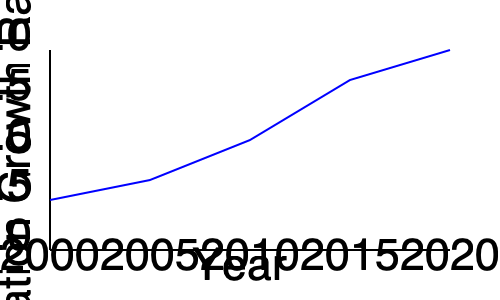Based on the line graph showing Nigeria's population growth rate from 2000 to 2020, calculate the average change in growth rate per year during this period. Express your answer as a percentage with two decimal places. To calculate the average change in growth rate per year:

1. Identify the starting and ending points:
   - 2000: 2.5%
   - 2020: 4.0%

2. Calculate the total change in growth rate:
   $4.0\% - 2.5\% = 1.5\%$

3. Determine the number of years in the period:
   $2020 - 2000 = 20$ years

4. Calculate the average change per year:
   $\frac{\text{Total change}}{\text{Number of years}} = \frac{1.5\%}{20} = 0.075\%$

5. Express the result as a percentage with two decimal places:
   $0.075\% = 0.08\%$ (rounded to two decimal places)

Therefore, the average change in Nigeria's population growth rate per year from 2000 to 2020 was 0.08%.
Answer: 0.08% 